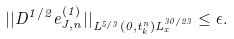Convert formula to latex. <formula><loc_0><loc_0><loc_500><loc_500>| | D ^ { 1 / 2 } e ^ { ( 1 ) } _ { J , n } | | _ { L ^ { 5 / 3 } ( 0 , t _ { k } ^ { n } ) L _ { x } ^ { 3 0 / 2 3 } } \leq \epsilon .</formula> 